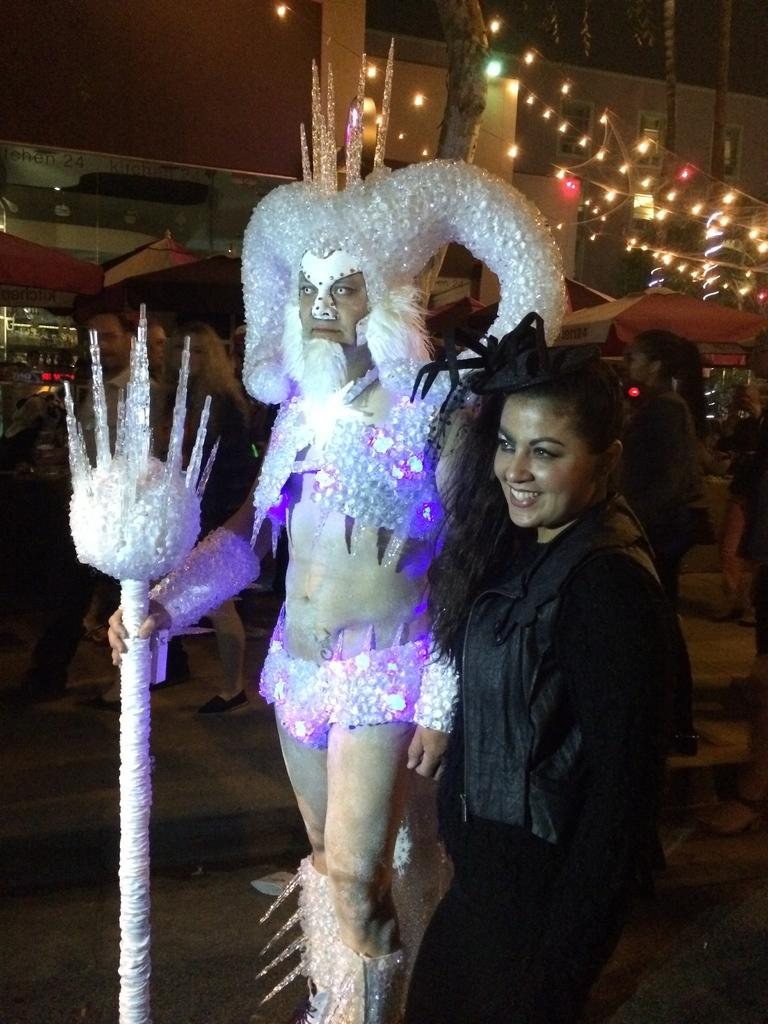How many people are in the image? There are two persons in the image. What are the persons wearing? The persons are wearing costumes. What can be seen in the background of the image? There are people walking and shops visible in the background of the image, as well as lightings. What type of grain is being sold in the shops visible in the image? There is no indication of any grain being sold in the shops visible in the image. How many snails can be seen crawling on the costumes of the persons in the image? There are no snails present in the image. 